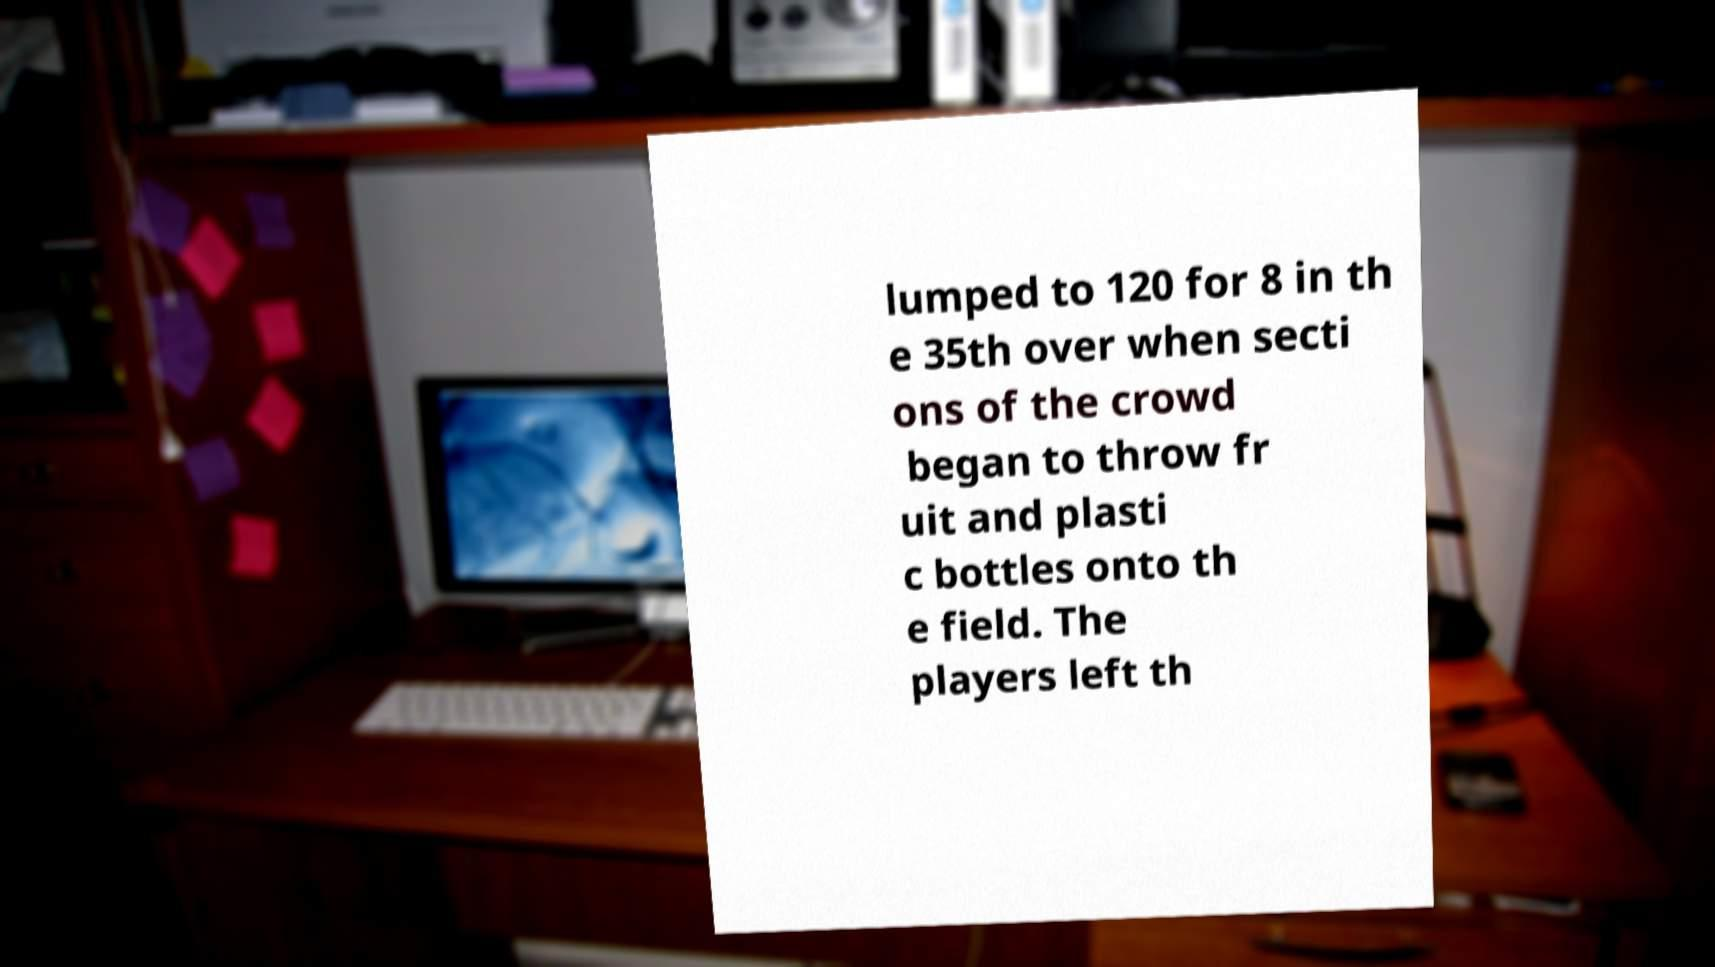There's text embedded in this image that I need extracted. Can you transcribe it verbatim? lumped to 120 for 8 in th e 35th over when secti ons of the crowd began to throw fr uit and plasti c bottles onto th e field. The players left th 